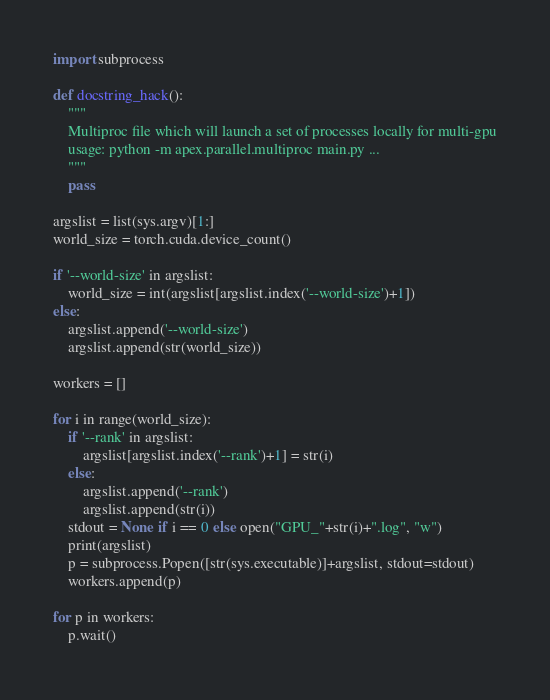<code> <loc_0><loc_0><loc_500><loc_500><_Python_>import subprocess

def docstring_hack():
    """
    Multiproc file which will launch a set of processes locally for multi-gpu
    usage: python -m apex.parallel.multiproc main.py ...
    """
    pass

argslist = list(sys.argv)[1:]
world_size = torch.cuda.device_count()

if '--world-size' in argslist:
    world_size = int(argslist[argslist.index('--world-size')+1])
else:
    argslist.append('--world-size')
    argslist.append(str(world_size))

workers = []

for i in range(world_size):
    if '--rank' in argslist:
        argslist[argslist.index('--rank')+1] = str(i)
    else:
        argslist.append('--rank')
        argslist.append(str(i))
    stdout = None if i == 0 else open("GPU_"+str(i)+".log", "w")
    print(argslist)
    p = subprocess.Popen([str(sys.executable)]+argslist, stdout=stdout)
    workers.append(p)

for p in workers:
    p.wait()
</code> 